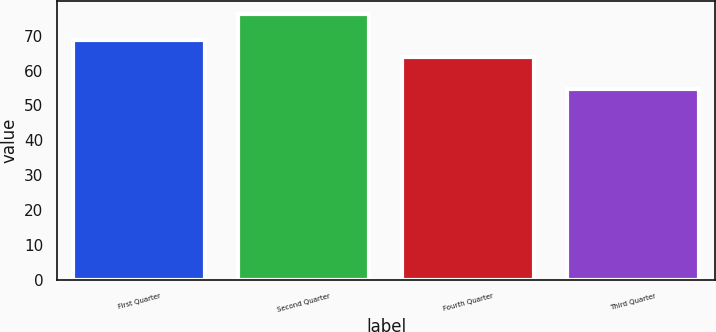Convert chart to OTSL. <chart><loc_0><loc_0><loc_500><loc_500><bar_chart><fcel>First Quarter<fcel>Second Quarter<fcel>Fourth Quarter<fcel>Third Quarter<nl><fcel>68.78<fcel>76.18<fcel>64.02<fcel>54.8<nl></chart> 